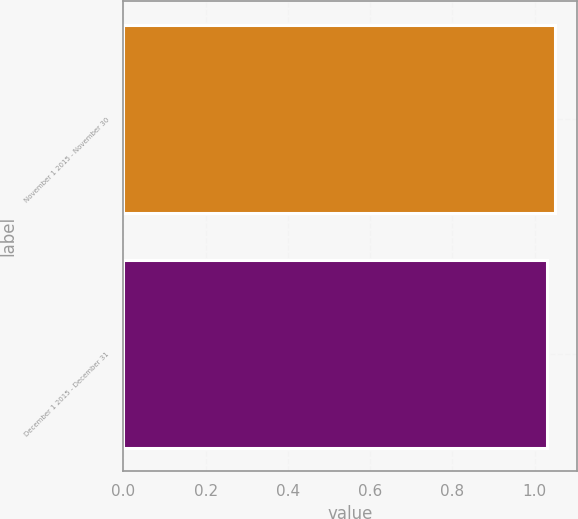Convert chart. <chart><loc_0><loc_0><loc_500><loc_500><bar_chart><fcel>November 1 2015 - November 30<fcel>December 1 2015 - December 31<nl><fcel>1.05<fcel>1.03<nl></chart> 